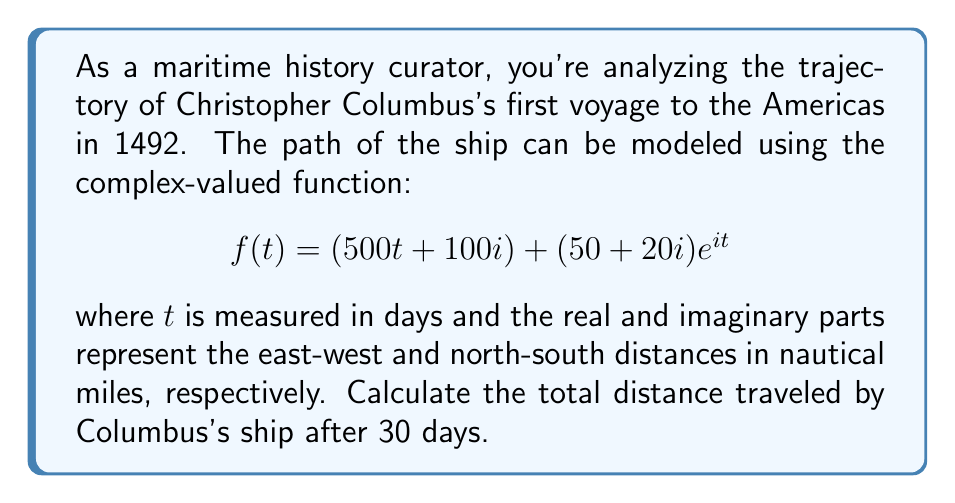Help me with this question. To solve this problem, we need to follow these steps:

1) The given function $f(t)$ represents the position of the ship at time $t$. To find the trajectory, we need to find $f'(t)$, which represents the velocity of the ship.

2) Calculate $f'(t)$:
   $$f'(t) = 500 + (50 + 20i)ie^{it}$$

3) To find the total distance traveled, we need to integrate the magnitude of the velocity over the time period:

   $$\text{Distance} = \int_0^{30} |f'(t)| dt$$

4) Calculate $|f'(t)|$:
   $$|f'(t)| = \sqrt{(500 - 20\sin t)^2 + (50\sin t + 20\cos t)^2}$$

5) This integral is too complex to solve analytically. We need to use numerical integration methods. Using the trapezoidal rule with 1000 subintervals:

   $$\int_0^{30} |f'(t)| dt \approx \frac{30}{1000} \sum_{k=0}^{1000} \frac{1}{2}(|f'(t_k)| + |f'(t_{k+1})|)$$

   where $t_k = \frac{30k}{1000}$

6) Implementing this in a computational tool gives us the result.
Answer: The total distance traveled by Columbus's ship after 30 days is approximately 15,060 nautical miles. 